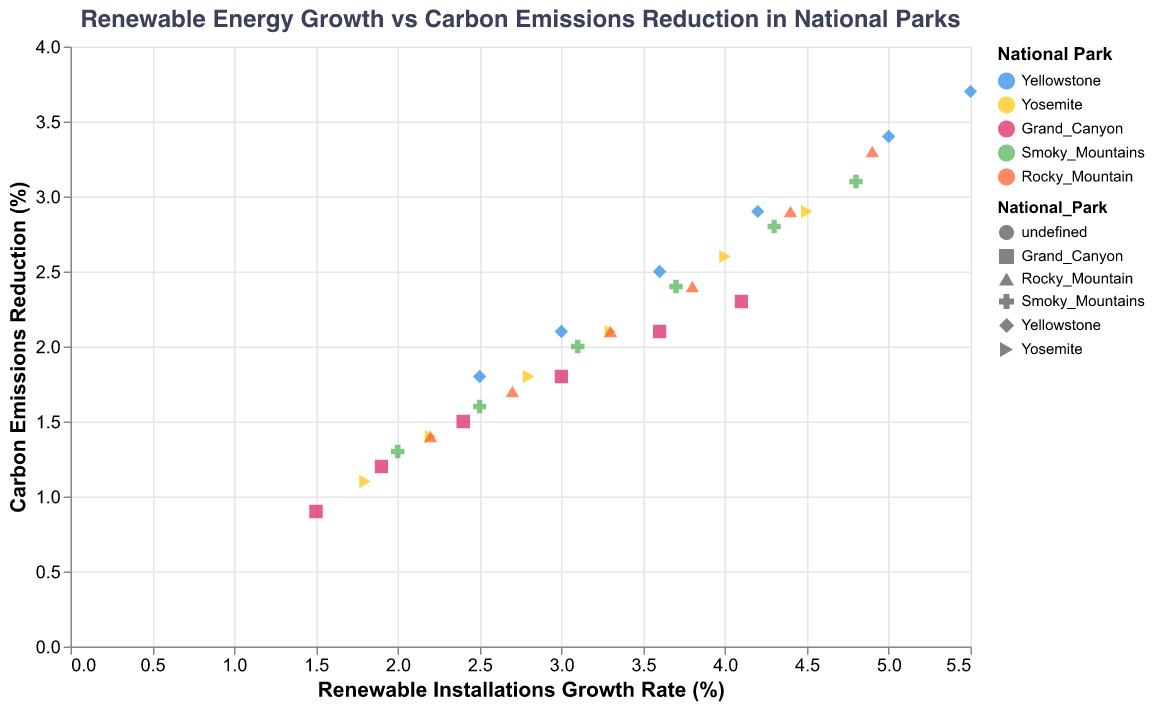What is the title of the figure? The title can be found at the top of the figure and it describes the contents and focus of the visualization.
Answer: Renewable Energy Growth vs Carbon Emissions Reduction in National Parks What parks are represented by the colors blue, yellow, and red? The legend in the figure assigns colors to specific national parks, where blue represents Yellowstone, yellow represents Yosemite, and red represents Grand Canyon.
Answer: Yellowstone, Yosemite, Grand Canyon What is the general trend between renewable installations growth rate and carbon emissions reduction? The trend line added to the scatter plot indicates an overall positive relationship between the growth rate of renewable energy installations and the reduction of carbon emissions.
Answer: Positive relationship Which national park shows the highest renewable installations growth rate in 2020? By looking at the data points for 2020 and checking the highest value on the x-axis, Yellowstone has the highest growth rate at 5.5%.
Answer: Yellowstone What is the average carbon emissions reduction across all national parks in 2020? To find the average, sum the carbon emissions reduction values for all parks in 2020 and divide by the number of parks: (3.7 + 2.9 + 2.3 + 3.1 + 3.3) / 5.
Answer: 3.06 Compare the growth rates between Yellowstone and Yosemite in 2018. From the data points for 2018, Yellowstone has a growth rate of 4.2% while Yosemite has a growth rate of 3.3%. Comparing these values, Yellowstone has a higher growth rate.
Answer: Yellowstone has a higher growth rate Which year did Grand Canyon achieve a carbon emissions reduction of 1.8%? By examining the data points for Grand Canyon, the year 2018 shows a carbon emissions reduction of 1.8%.
Answer: 2018 Is there any national park that shows a reduction of at least 3.0% in carbon emissions in 2019? By checking the y-axis value for each park in 2019, Yellowstone (3.4%) and Rocky Mountain (2.9%, slightly less than 3.0%) are identified.
Answer: Yellowstone What is the correlation between the renewable installations growth rate and carbon emissions reduction? The correlation can be inferred from the trend line, which shows a positive slope indicating a positive correlation.
Answer: Positive How much greater is the renewable installations growth rate for Rocky Mountain compared to Grand Canyon in 2020? In 2020, Rocky Mountain has a growth rate of 4.9% and Grand Canyon has a growth rate of 4.1%. The difference can be calculated as 4.9 - 4.1 = 0.8%.
Answer: 0.8% 